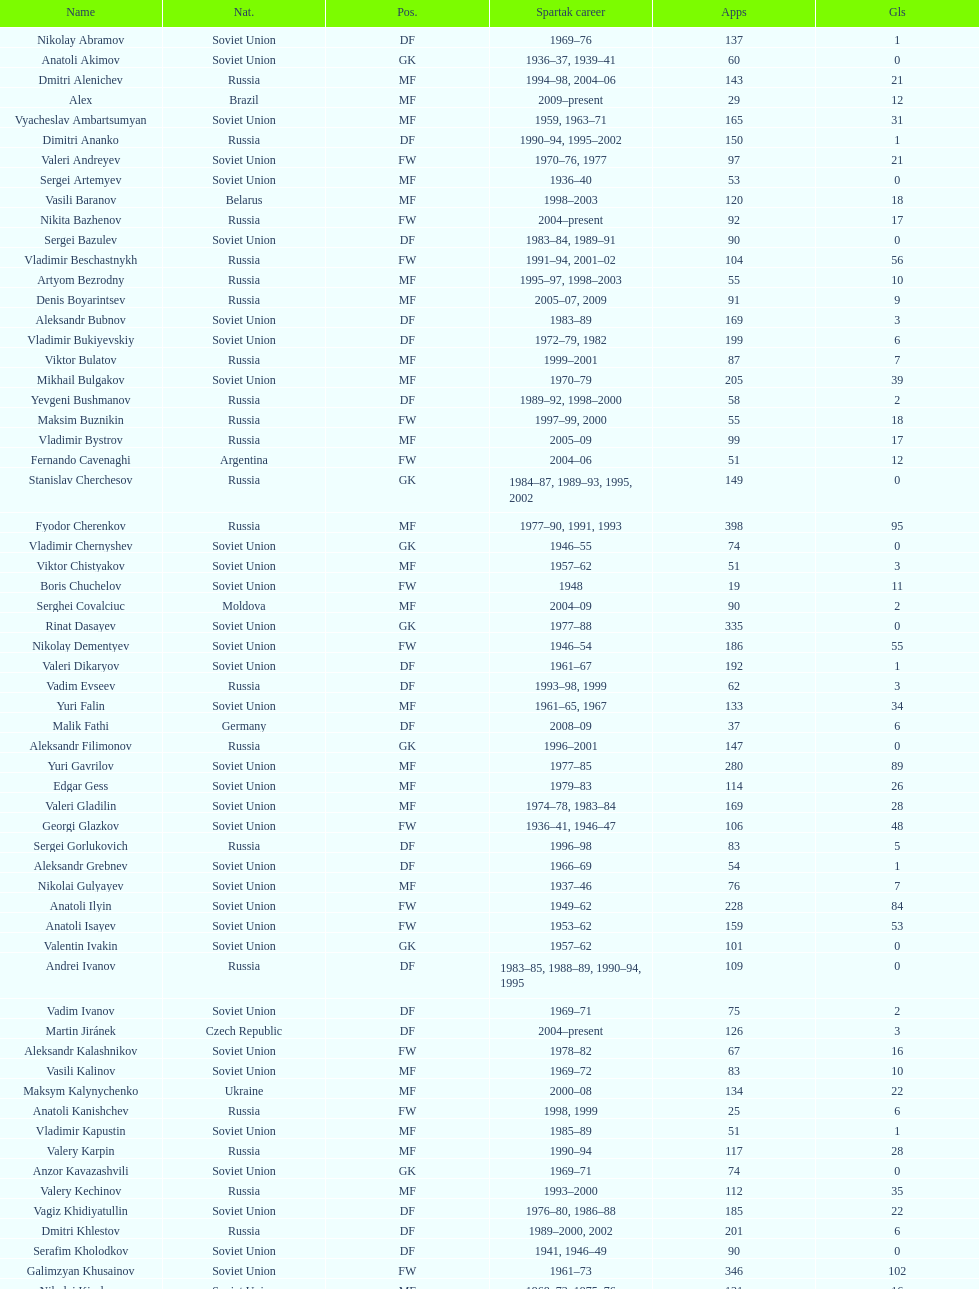Name two players with goals above 15. Dmitri Alenichev, Vyacheslav Ambartsumyan. 